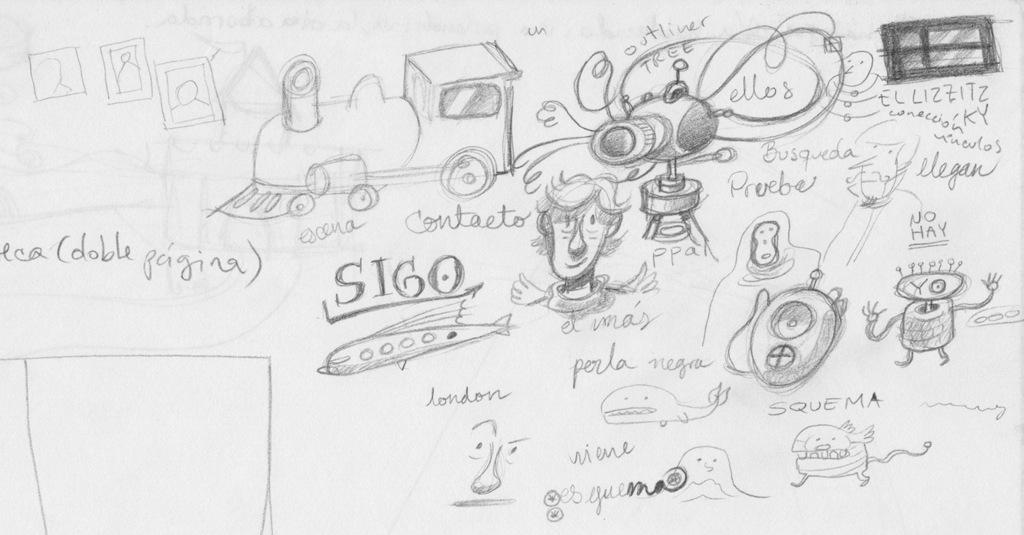What type of illustrations are present in the image? There are diagrams in the image. What is the main subject of the diagrams? The diagrams depict a train engine. What is unique about the design of the train engine? The train engine is in the shape of a man's face. How many bikes are parked next to the train engine in the image? There are no bikes present in the image; it only features diagrams of a train engine. What type of wing is attached to the train engine in the image? There is no wing attached to the train engine in the image; it is in the shape of a man's face. 